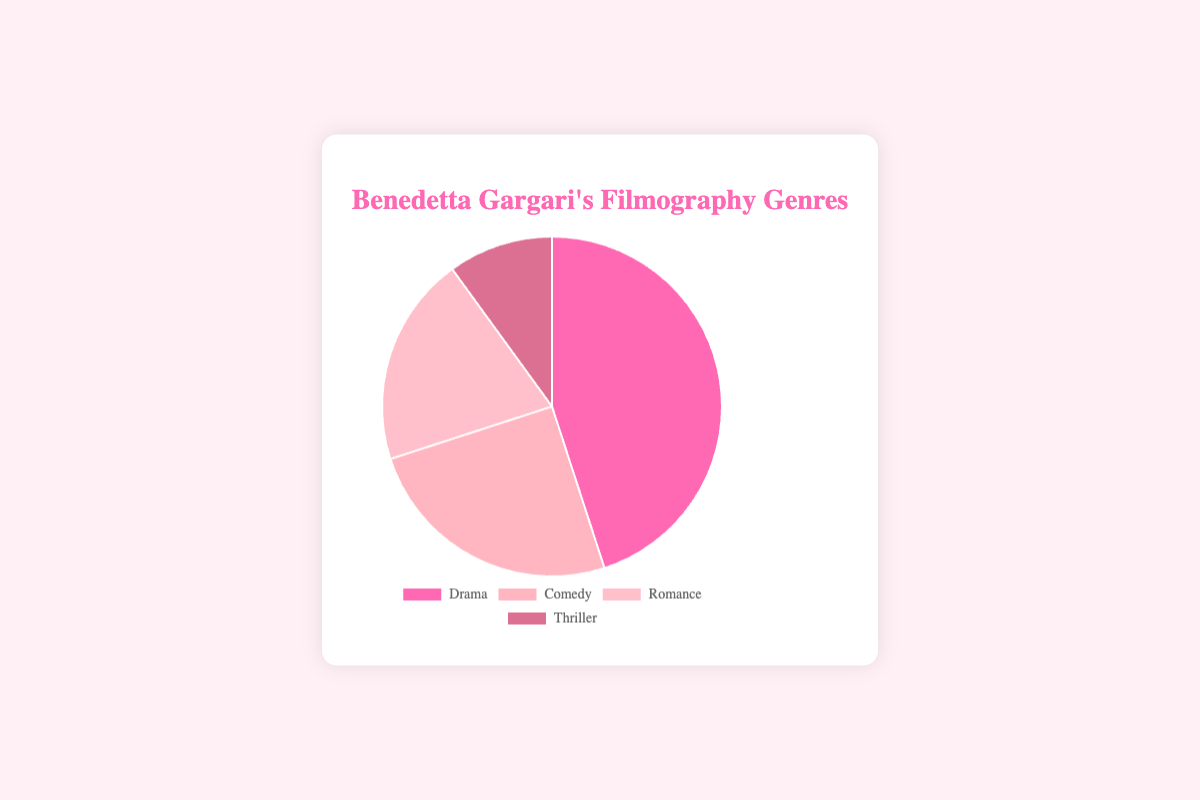What is the most prevalent genre in Benedetta Gargari's filmography? The pie chart shows the percentage distribution of different genres. The largest segment represents 45%, which corresponds to Drama.
Answer: Drama What is the combined percentage of Comedy and Romance genres? According to the chart, Comedy is 25% and Romance is 20%. Therefore, their combined percentage is 25% + 20% = 45%.
Answer: 45% Which genre is least represented in Benedetta Gargari's filmography? The smallest segment in the pie chart represents 10%, which corresponds to Thriller.
Answer: Thriller By how much does the percentage of Drama exceed that of Romance? Drama accounts for 45%, while Romance is 20%. The difference is 45% - 20% = 25%.
Answer: 25% If you compare Comedy and Thriller, how many times more is Comedy featured compared to Thriller? Comedy accounts for 25% and Thriller accounts for 10%. To find out how many times more, divide 25% by 10%. 25 / 10 = 2.5 times.
Answer: 2.5 times What is the total percentage covered by genres other than Drama? The other genres are Comedy, Romance, and Thriller, which are 25%, 20%, and 10% respectively. Adding these gives 25% + 20% + 10% = 55%.
Answer: 55% What color represents the Romance genre? The pie chart uses different colors for each genre. Romance is assigned a specific shade.
Answer: A shade of pink (light pink) How much greater is the representation of Comedy over Thriller in percentage terms? The chart shows Comedy at 25% and Thriller at 10%. The percentage difference is 25% - 10% = 15%.
Answer: 15% Which two genres combined amount to exactly half of Benedetta Gargari's filmography? Drama is 45% and Thriller is 10%, together they account for 55% which exceeds half. For exactly half, we consider Comedy (25%) and Romance (20%), which total 45%. None match exactly half (50%).
Answer: None What percentage of Benedetta Gargari's filmography falls under genres other than Romance? Romance is 20%, so the rest of the filmography includes Drama (45%), Comedy (25%), and Thriller (10%). Their total is 45% + 25% + 10% = 80%.
Answer: 80% 